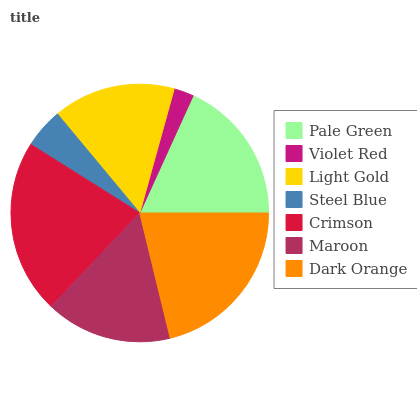Is Violet Red the minimum?
Answer yes or no. Yes. Is Crimson the maximum?
Answer yes or no. Yes. Is Light Gold the minimum?
Answer yes or no. No. Is Light Gold the maximum?
Answer yes or no. No. Is Light Gold greater than Violet Red?
Answer yes or no. Yes. Is Violet Red less than Light Gold?
Answer yes or no. Yes. Is Violet Red greater than Light Gold?
Answer yes or no. No. Is Light Gold less than Violet Red?
Answer yes or no. No. Is Maroon the high median?
Answer yes or no. Yes. Is Maroon the low median?
Answer yes or no. Yes. Is Steel Blue the high median?
Answer yes or no. No. Is Violet Red the low median?
Answer yes or no. No. 